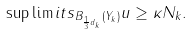<formula> <loc_0><loc_0><loc_500><loc_500>\sup \lim i t s _ { B _ { \frac { 1 } { 3 } d _ { k } } ( Y _ { k } ) } u \geq \kappa N _ { k } .</formula> 